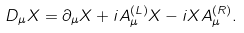Convert formula to latex. <formula><loc_0><loc_0><loc_500><loc_500>D _ { \mu } X = \partial _ { \mu } X + i A ^ { ( L ) } _ { \mu } X - i X A ^ { ( R ) } _ { \mu } .</formula> 